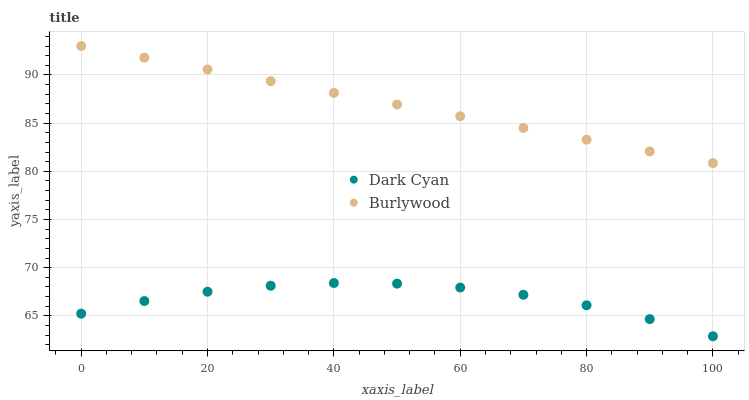Does Dark Cyan have the minimum area under the curve?
Answer yes or no. Yes. Does Burlywood have the maximum area under the curve?
Answer yes or no. Yes. Does Burlywood have the minimum area under the curve?
Answer yes or no. No. Is Burlywood the smoothest?
Answer yes or no. Yes. Is Dark Cyan the roughest?
Answer yes or no. Yes. Is Burlywood the roughest?
Answer yes or no. No. Does Dark Cyan have the lowest value?
Answer yes or no. Yes. Does Burlywood have the lowest value?
Answer yes or no. No. Does Burlywood have the highest value?
Answer yes or no. Yes. Is Dark Cyan less than Burlywood?
Answer yes or no. Yes. Is Burlywood greater than Dark Cyan?
Answer yes or no. Yes. Does Dark Cyan intersect Burlywood?
Answer yes or no. No. 